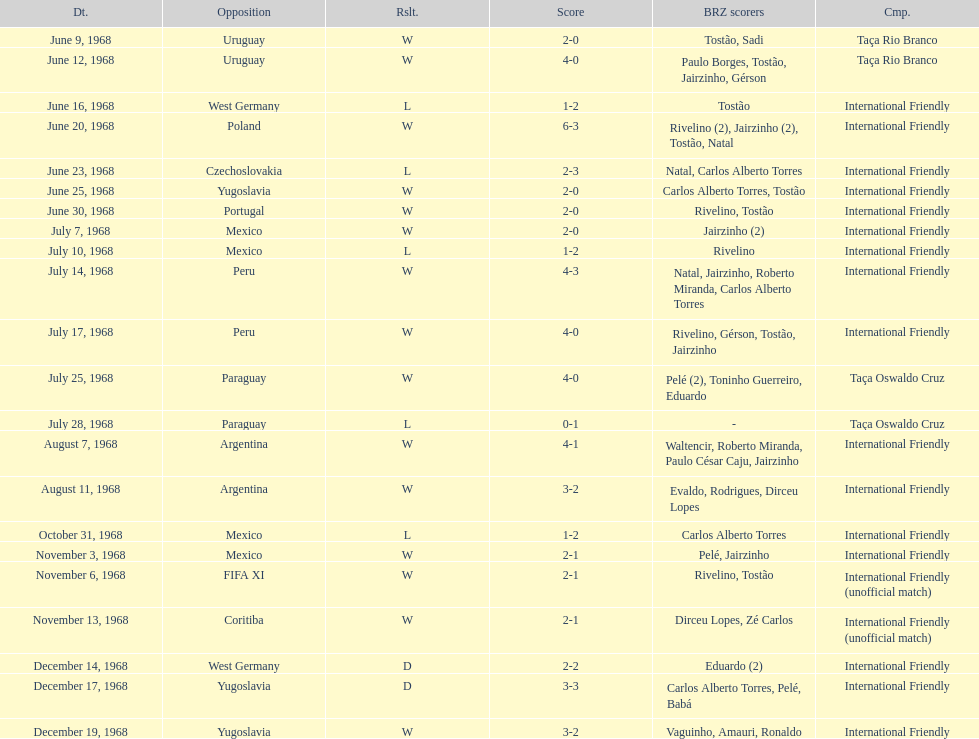The most goals scored by brazil in a game 6. Help me parse the entirety of this table. {'header': ['Dt.', 'Opposition', 'Rslt.', 'Score', 'BRZ scorers', 'Cmp.'], 'rows': [['June 9, 1968', 'Uruguay', 'W', '2-0', 'Tostão, Sadi', 'Taça Rio Branco'], ['June 12, 1968', 'Uruguay', 'W', '4-0', 'Paulo Borges, Tostão, Jairzinho, Gérson', 'Taça Rio Branco'], ['June 16, 1968', 'West Germany', 'L', '1-2', 'Tostão', 'International Friendly'], ['June 20, 1968', 'Poland', 'W', '6-3', 'Rivelino (2), Jairzinho (2), Tostão, Natal', 'International Friendly'], ['June 23, 1968', 'Czechoslovakia', 'L', '2-3', 'Natal, Carlos Alberto Torres', 'International Friendly'], ['June 25, 1968', 'Yugoslavia', 'W', '2-0', 'Carlos Alberto Torres, Tostão', 'International Friendly'], ['June 30, 1968', 'Portugal', 'W', '2-0', 'Rivelino, Tostão', 'International Friendly'], ['July 7, 1968', 'Mexico', 'W', '2-0', 'Jairzinho (2)', 'International Friendly'], ['July 10, 1968', 'Mexico', 'L', '1-2', 'Rivelino', 'International Friendly'], ['July 14, 1968', 'Peru', 'W', '4-3', 'Natal, Jairzinho, Roberto Miranda, Carlos Alberto Torres', 'International Friendly'], ['July 17, 1968', 'Peru', 'W', '4-0', 'Rivelino, Gérson, Tostão, Jairzinho', 'International Friendly'], ['July 25, 1968', 'Paraguay', 'W', '4-0', 'Pelé (2), Toninho Guerreiro, Eduardo', 'Taça Oswaldo Cruz'], ['July 28, 1968', 'Paraguay', 'L', '0-1', '-', 'Taça Oswaldo Cruz'], ['August 7, 1968', 'Argentina', 'W', '4-1', 'Waltencir, Roberto Miranda, Paulo César Caju, Jairzinho', 'International Friendly'], ['August 11, 1968', 'Argentina', 'W', '3-2', 'Evaldo, Rodrigues, Dirceu Lopes', 'International Friendly'], ['October 31, 1968', 'Mexico', 'L', '1-2', 'Carlos Alberto Torres', 'International Friendly'], ['November 3, 1968', 'Mexico', 'W', '2-1', 'Pelé, Jairzinho', 'International Friendly'], ['November 6, 1968', 'FIFA XI', 'W', '2-1', 'Rivelino, Tostão', 'International Friendly (unofficial match)'], ['November 13, 1968', 'Coritiba', 'W', '2-1', 'Dirceu Lopes, Zé Carlos', 'International Friendly (unofficial match)'], ['December 14, 1968', 'West Germany', 'D', '2-2', 'Eduardo (2)', 'International Friendly'], ['December 17, 1968', 'Yugoslavia', 'D', '3-3', 'Carlos Alberto Torres, Pelé, Babá', 'International Friendly'], ['December 19, 1968', 'Yugoslavia', 'W', '3-2', 'Vaguinho, Amauri, Ronaldo', 'International Friendly']]} 